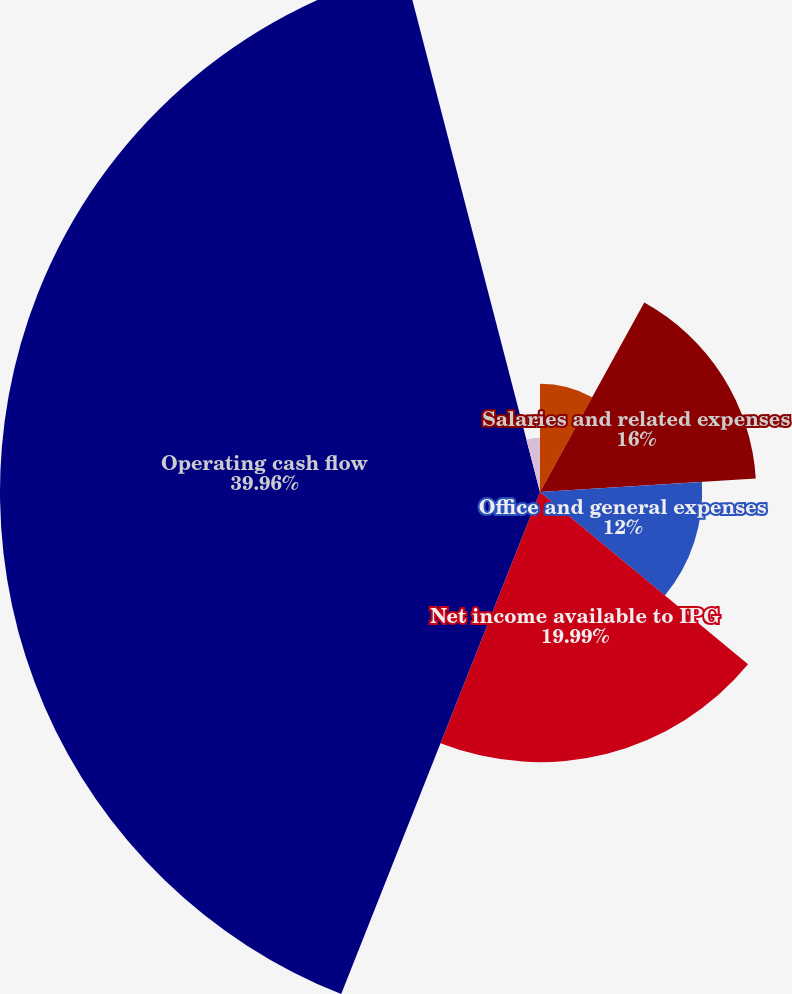Convert chart to OTSL. <chart><loc_0><loc_0><loc_500><loc_500><pie_chart><fcel>Operating margin<fcel>Salaries and related expenses<fcel>Office and general expenses<fcel>Net income available to IPG<fcel>Operating cash flow<fcel>Basic<fcel>Diluted<nl><fcel>8.01%<fcel>16.0%<fcel>12.0%<fcel>19.99%<fcel>39.96%<fcel>4.02%<fcel>0.02%<nl></chart> 